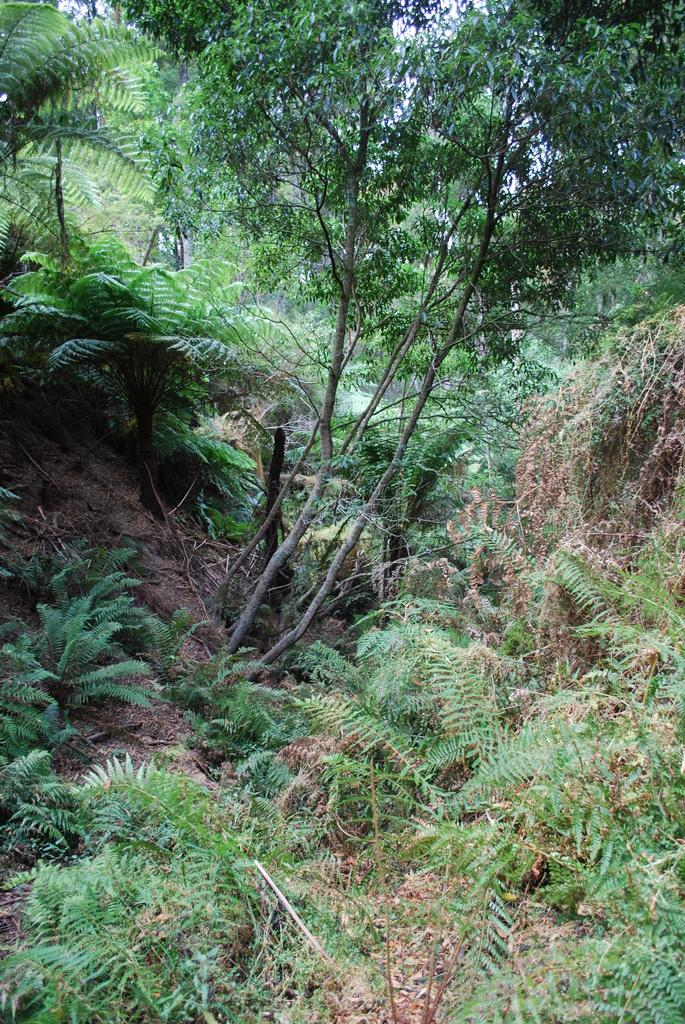What type of vegetation can be seen in the image? There are trees and plants in the image. What part of the natural environment is visible in the image? The sky is visible in the background of the image. What type of locket is hanging from the tree in the image? There is no locket present in the image; it only features trees, plants, and the sky. 